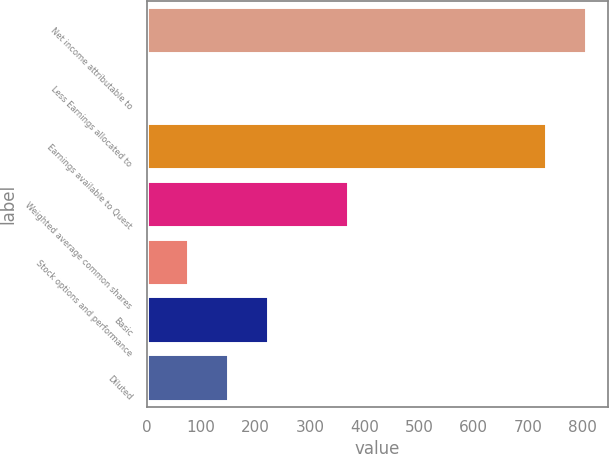<chart> <loc_0><loc_0><loc_500><loc_500><bar_chart><fcel>Net income attributable to<fcel>Less Earnings allocated to<fcel>Earnings available to Quest<fcel>Weighted average common shares<fcel>Stock options and performance<fcel>Basic<fcel>Diluted<nl><fcel>806.3<fcel>3<fcel>733<fcel>369.5<fcel>76.3<fcel>222.9<fcel>149.6<nl></chart> 